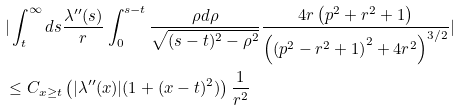<formula> <loc_0><loc_0><loc_500><loc_500>& | \int _ { t } ^ { \infty } d s \frac { \lambda ^ { \prime \prime } ( s ) } { r } \int _ { 0 } ^ { s - t } \frac { \rho d \rho } { \sqrt { ( s - t ) ^ { 2 } - \rho ^ { 2 } } } \frac { 4 r \left ( p ^ { 2 } + r ^ { 2 } + 1 \right ) } { \left ( \left ( p ^ { 2 } - r ^ { 2 } + 1 \right ) ^ { 2 } + 4 r ^ { 2 } \right ) ^ { 3 / 2 } } | \\ & \leq C _ { x \geq t } \left ( | \lambda ^ { \prime \prime } ( x ) | ( 1 + ( x - t ) ^ { 2 } ) \right ) \frac { 1 } { r ^ { 2 } }</formula> 